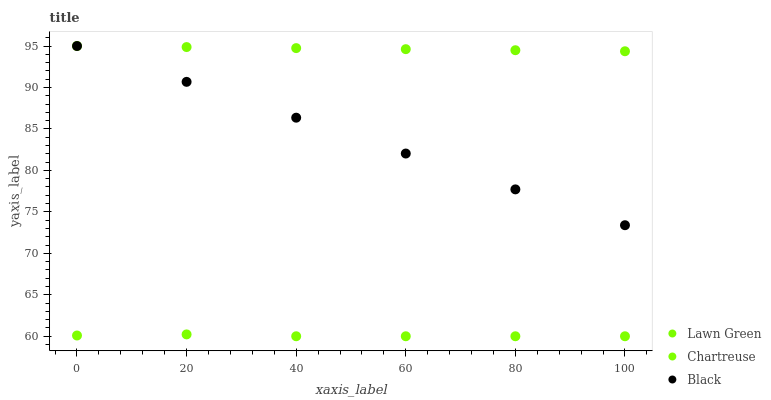Does Chartreuse have the minimum area under the curve?
Answer yes or no. Yes. Does Lawn Green have the maximum area under the curve?
Answer yes or no. Yes. Does Black have the minimum area under the curve?
Answer yes or no. No. Does Black have the maximum area under the curve?
Answer yes or no. No. Is Black the smoothest?
Answer yes or no. Yes. Is Chartreuse the roughest?
Answer yes or no. Yes. Is Chartreuse the smoothest?
Answer yes or no. No. Is Black the roughest?
Answer yes or no. No. Does Chartreuse have the lowest value?
Answer yes or no. Yes. Does Black have the lowest value?
Answer yes or no. No. Does Black have the highest value?
Answer yes or no. Yes. Does Chartreuse have the highest value?
Answer yes or no. No. Is Chartreuse less than Lawn Green?
Answer yes or no. Yes. Is Black greater than Chartreuse?
Answer yes or no. Yes. Does Lawn Green intersect Black?
Answer yes or no. Yes. Is Lawn Green less than Black?
Answer yes or no. No. Is Lawn Green greater than Black?
Answer yes or no. No. Does Chartreuse intersect Lawn Green?
Answer yes or no. No. 